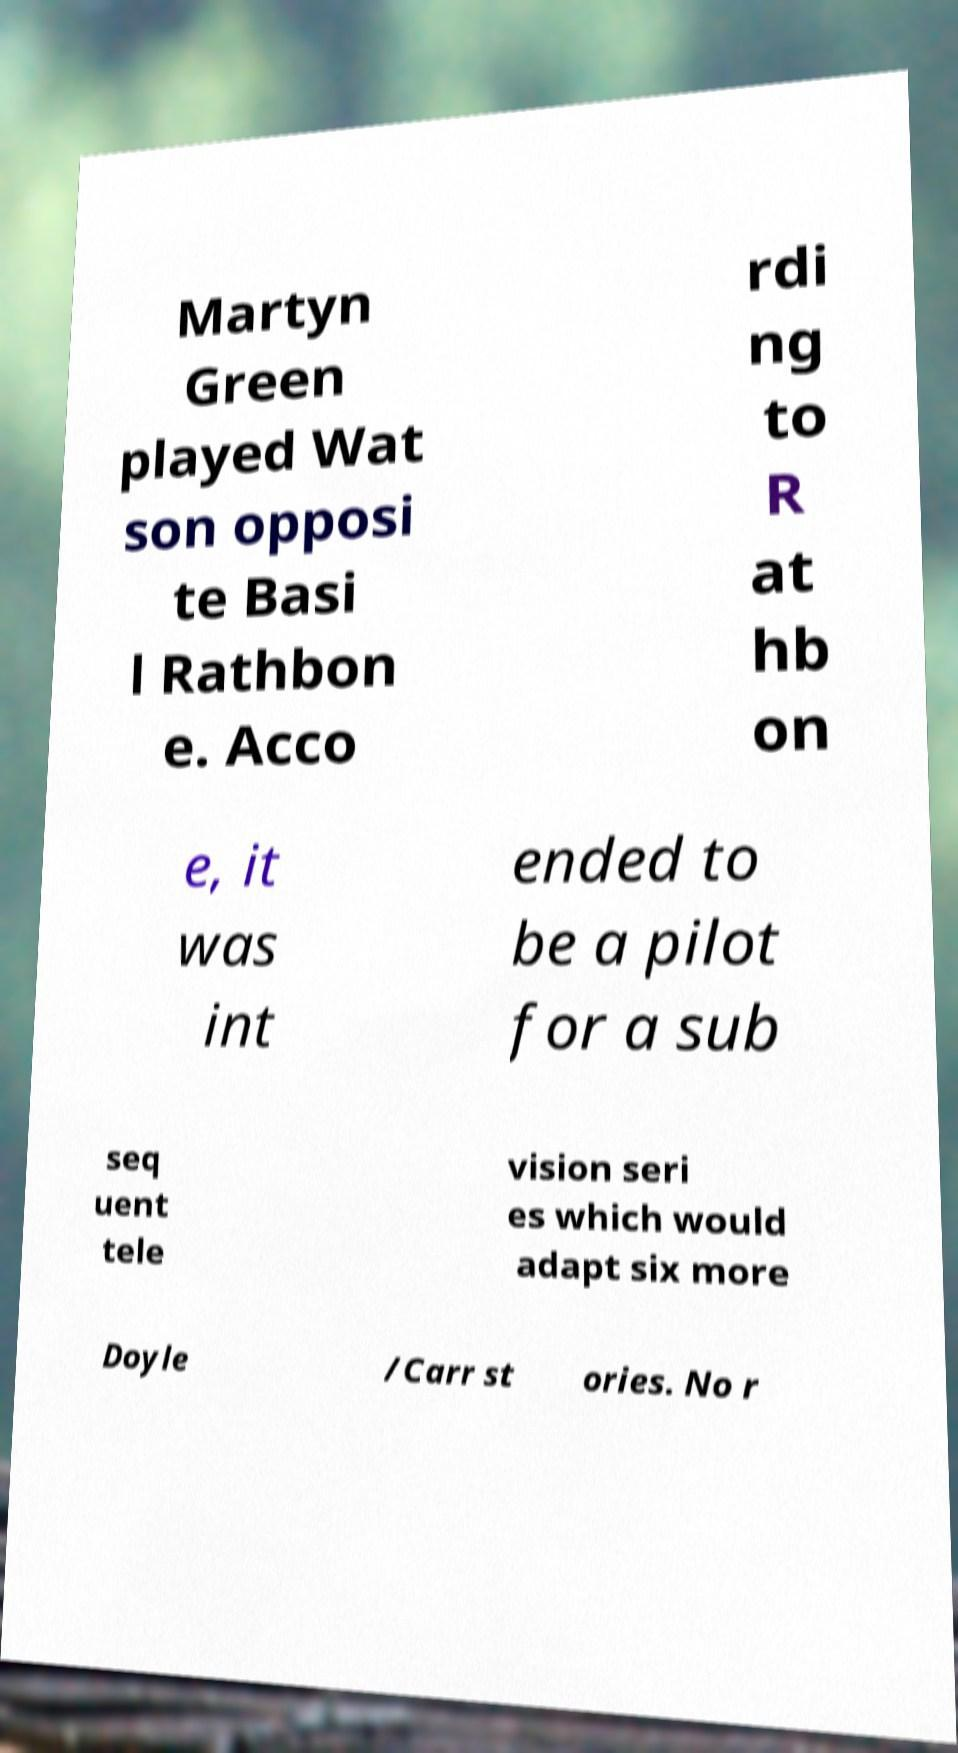For documentation purposes, I need the text within this image transcribed. Could you provide that? Martyn Green played Wat son opposi te Basi l Rathbon e. Acco rdi ng to R at hb on e, it was int ended to be a pilot for a sub seq uent tele vision seri es which would adapt six more Doyle /Carr st ories. No r 